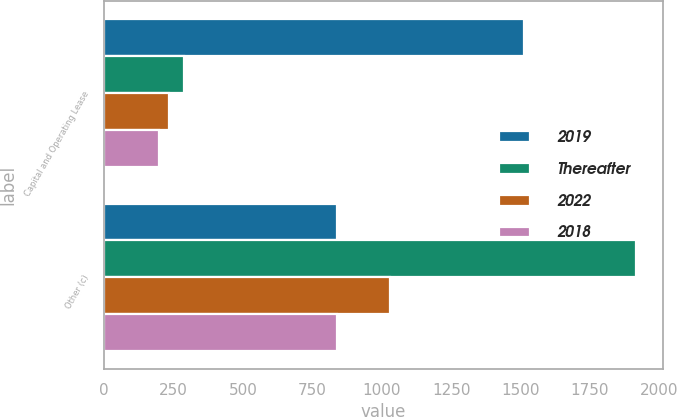<chart> <loc_0><loc_0><loc_500><loc_500><stacked_bar_chart><ecel><fcel>Capital and Operating Lease<fcel>Other (c)<nl><fcel>2019<fcel>1512<fcel>839<nl><fcel>Thereafter<fcel>286<fcel>1917<nl><fcel>2022<fcel>235<fcel>1031<nl><fcel>2018<fcel>199<fcel>839<nl></chart> 